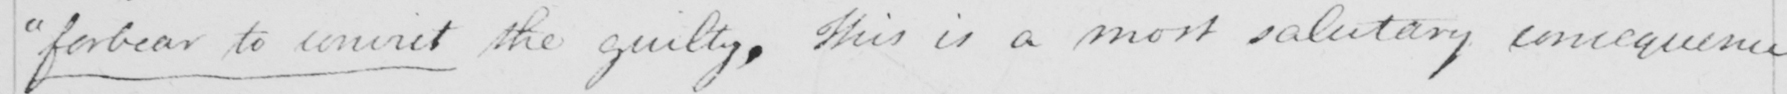Can you tell me what this handwritten text says? " forbear to convict the guilty . This is a most salutary consequence 